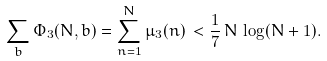<formula> <loc_0><loc_0><loc_500><loc_500>\sum _ { b } \Phi _ { 3 } ( N , b ) = \sum _ { n = 1 } ^ { N } \mu _ { 3 } ( n ) \, < \frac { 1 } { 7 } \, N \, \log ( N + 1 ) .</formula> 